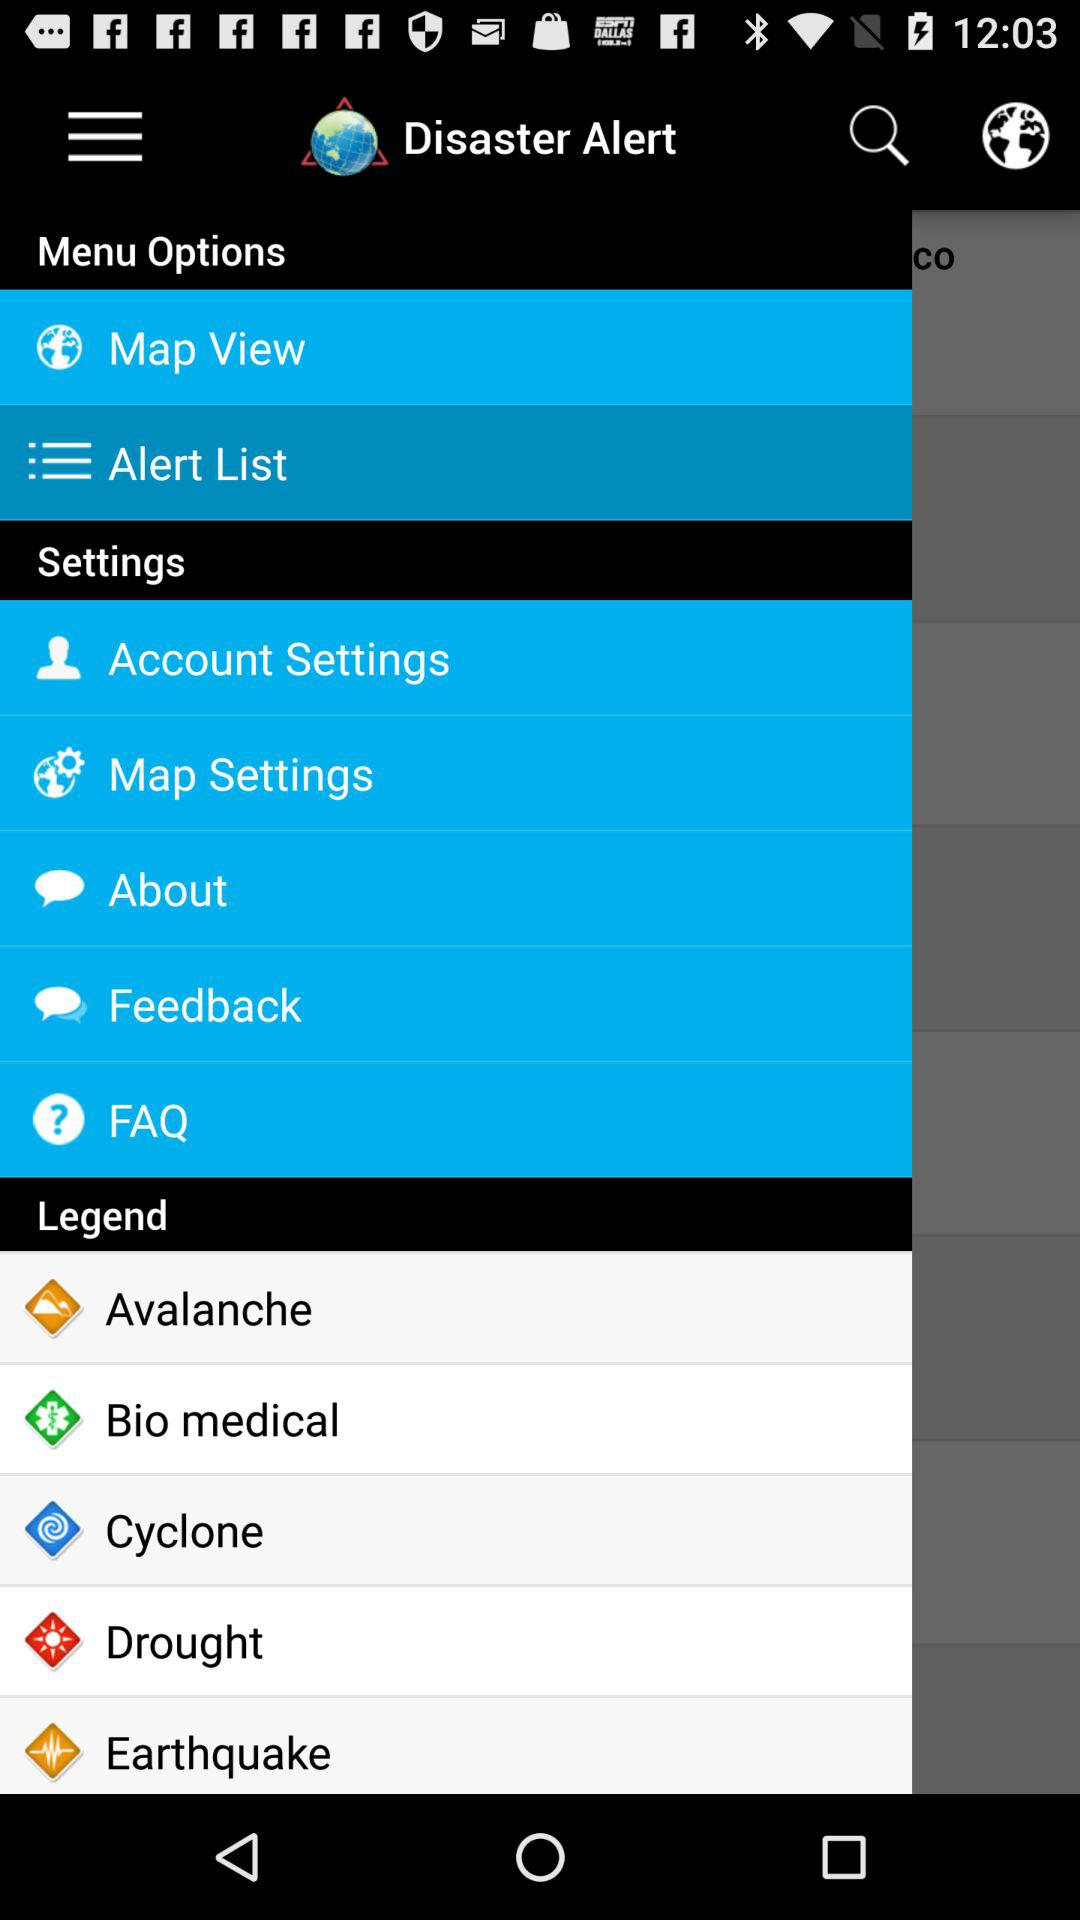What is the application name? The application name is "Disaster Alert". 